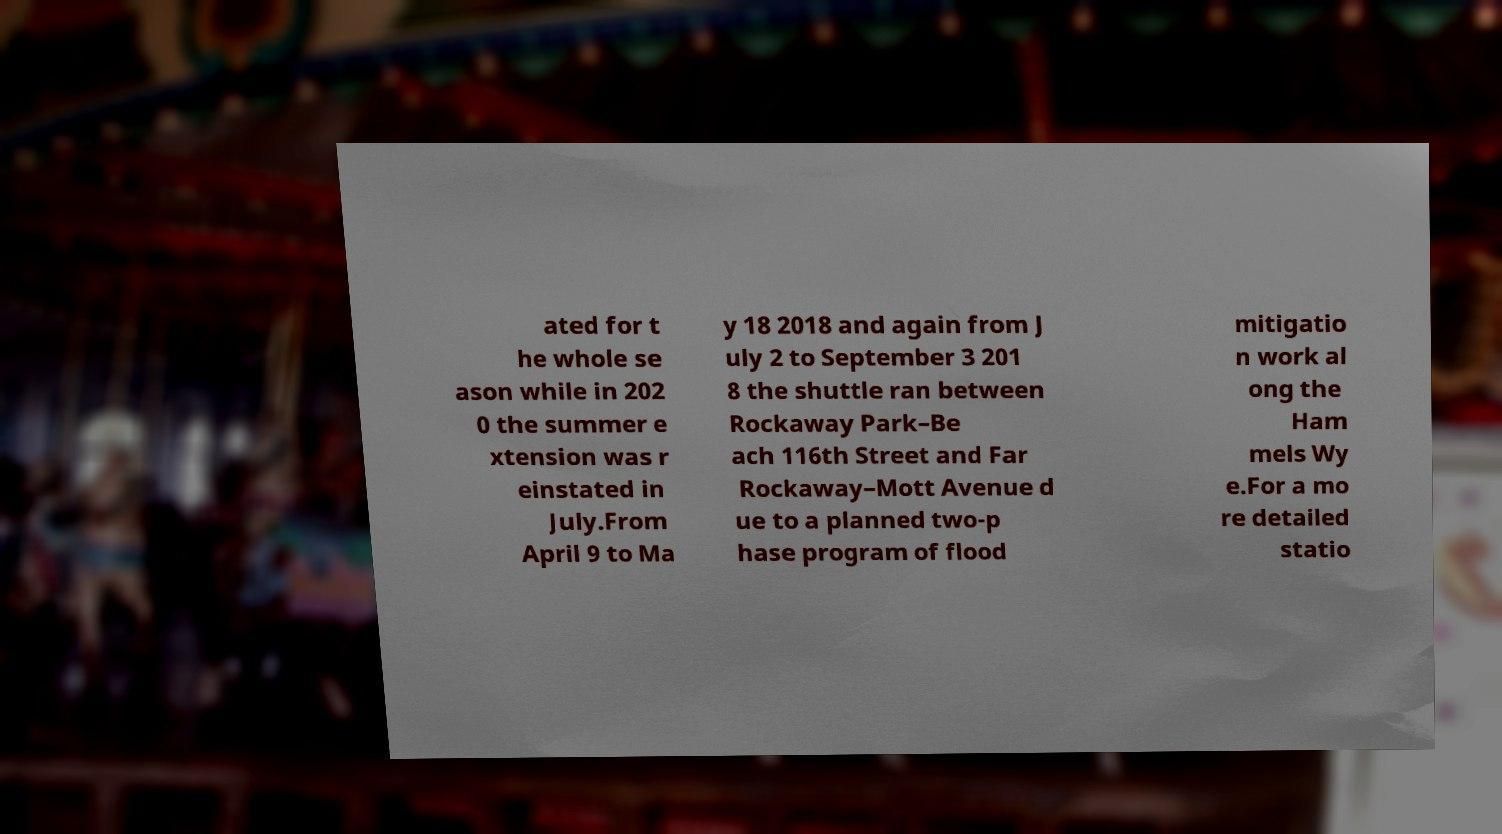Could you extract and type out the text from this image? ated for t he whole se ason while in 202 0 the summer e xtension was r einstated in July.From April 9 to Ma y 18 2018 and again from J uly 2 to September 3 201 8 the shuttle ran between Rockaway Park–Be ach 116th Street and Far Rockaway–Mott Avenue d ue to a planned two-p hase program of flood mitigatio n work al ong the Ham mels Wy e.For a mo re detailed statio 